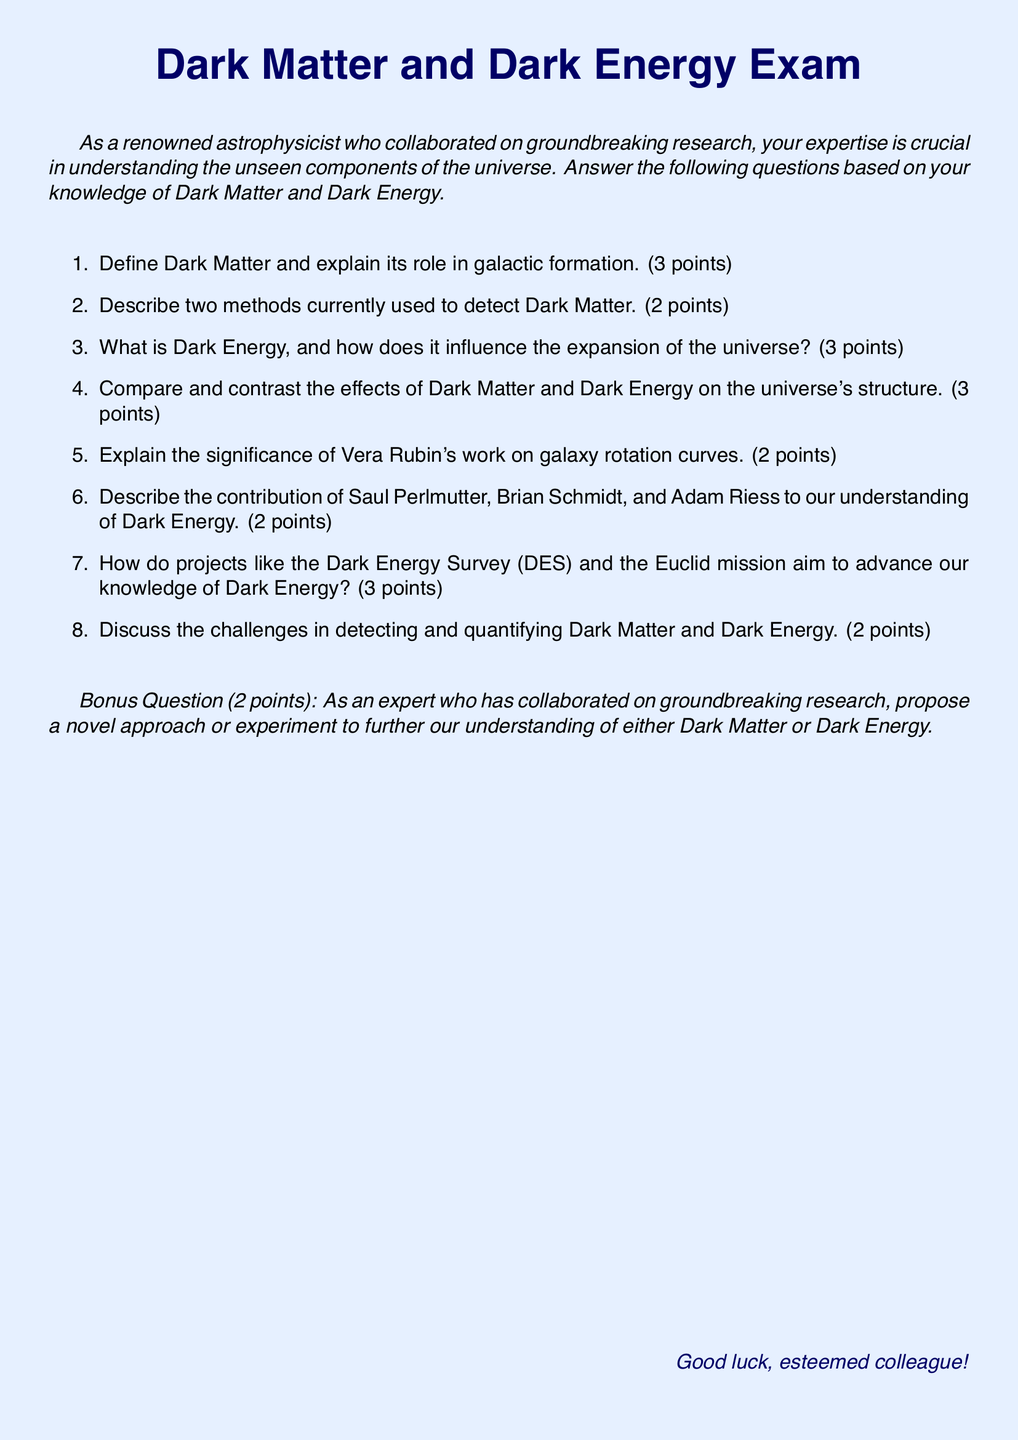what is the total number of points for the exam? The total points for the exam are calculated by adding the individual point values for each question, which are 3, 2, 3, 3, 2, 2, 3, and 2 for the main questions and 2 for the bonus question. This sums up to 20 points.
Answer: 20 points who contributed to our understanding of Dark Energy? The document mentions Saul Perlmutter, Brian Schmidt, and Adam Riess as key contributors to our understanding of Dark Energy.
Answer: Saul Perlmutter, Brian Schmidt, and Adam Riess what are the two methods for Dark Matter detection mentioned? The document requires candidates to describe two methods for detecting Dark Matter, but does not specify them within the text. Hence, only the method types can be inferred based on general knowledge.
Answer: (Not specified in the document) how many points is the significance of Vera Rubin's work worth? The significance of Vera Rubin's work is stated to be worth 2 points in the exam.
Answer: 2 points what is the main focus of the bonus question? The bonus question asks for a novel approach or experiment related to either Dark Matter or Dark Energy, based on the expertise of the examinee.
Answer: A novel approach or experiment how many points are awarded for the question about Dark Energy Survey and Euclid mission? The question about the aims of the Dark Energy Survey (DES) and the Euclid mission is worth 3 points.
Answer: 3 points how many questions are there in total on the exam? The exam lists eight main questions and one bonus question, totaling nine questions.
Answer: 9 questions what color is used for the main title in the document? The main title is colored dark blue as specified in the document formatting.
Answer: dark blue 